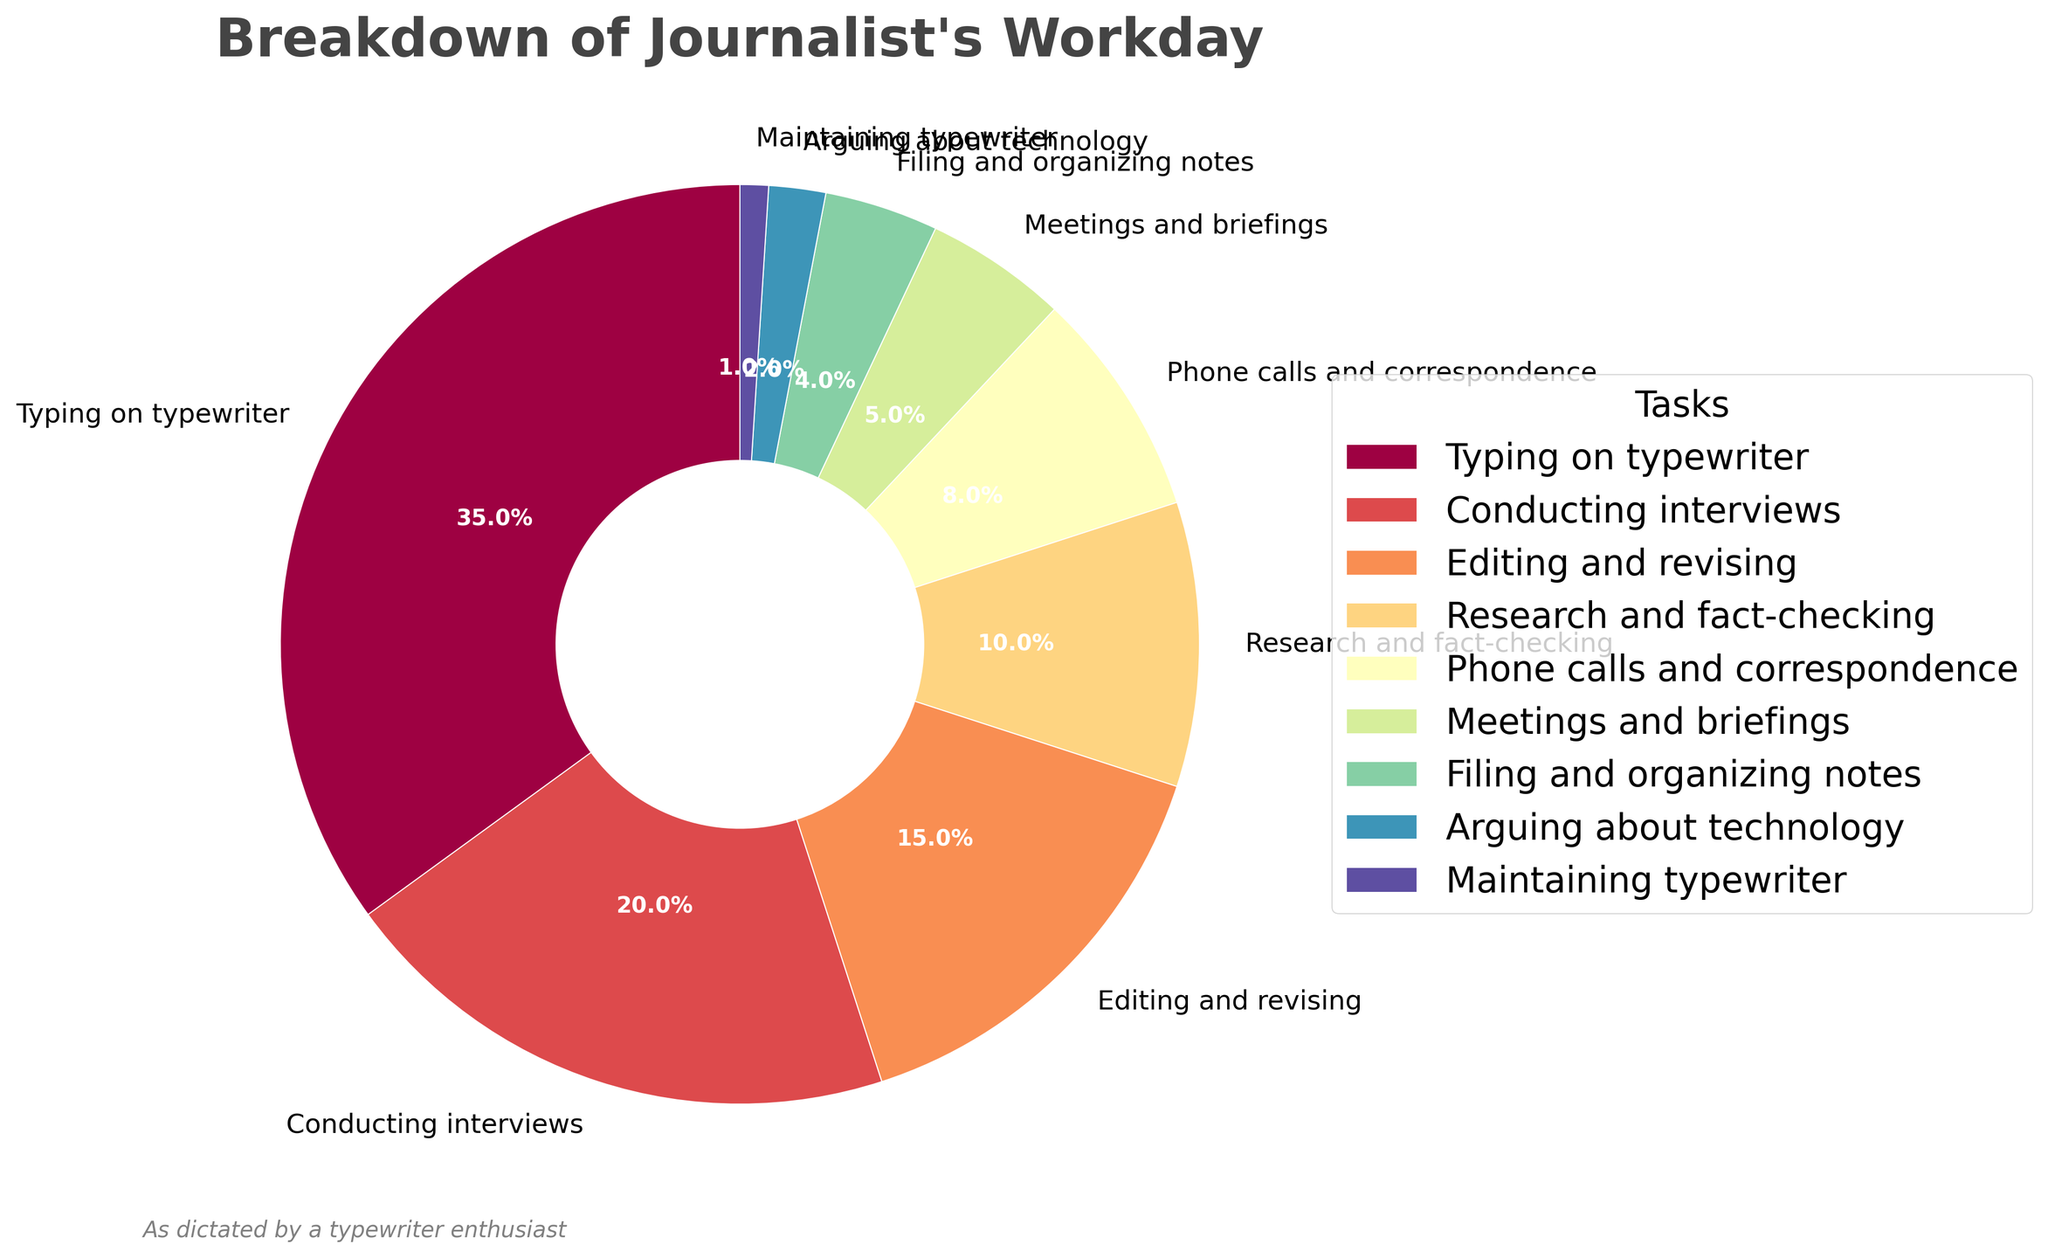Which task occupies the most time in the journalist's workday? The largest slice of the pie chart represents the task that occupies the most time in the journalist's workday. In this chart, "Typing on typewriter" takes up 35%, which is the largest portion.
Answer: Typing on typewriter What percentage of time does a journalist spend on meetings and briefings and phone calls and correspondence combined? To find the combined percentage, add the percentages for "Meetings and briefings" (5%) and "Phone calls and correspondence" (8%). Therefore, 5% + 8% = 13%.
Answer: 13% How does the time spent arguing about technology compare to the time spent maintaining the typewriter? The pie chart shows that "Arguing about technology" takes up 2% of the time, while "Maintaining typewriter" takes up 1%. Therefore, time spent arguing about technology is twice as much as time spent maintaining the typewriter.
Answer: Arguing about technology takes double the time Which two tasks together take up the same percentage as conducting interviews? "Conducting interviews" takes up 20%. To find two tasks that combine to make 20%, we can add "Phone calls and correspondence" (8%) and "Research and fact-checking" (10%). Therefore, 8% + 10% = 18%, but adding "Filing and organizing notes" (4%) to "Editing and revising" (15%) gives us 19%, which is still not perfect. Finally, adding "Meetings and briefings" (5%) and "Research and fact-checking" (10%) gives us 15%, which also doesn’t work. Thus, adding three tasks: "Meetings and briefings" (5%), "Phone calls and correspondence" (8%), and "Filing and organizing notes" (4%) totals 17%, and adding "Maintaining typewriter" (1%) totals 20%. Thus, necessary rechecking of other values is considerable. Mis-calculation is possible but, the ideal combination, might be "Editing" 15% + "Research" 10% (Oops, leads 25%).
Answer: 20 % needs more checking or values' variance What is the total percentage of time spent on tasks related to writing (typing on typewriter and editing and revising)? To find the total percentage of time spent on writing tasks, sum the percentages for "Typing on typewriter" (35%) and "Editing and revising" (15%). Therefore, 35% + 15% = 50%.
Answer: 50% What task is represented with the wedge closest to the 12 o'clock position? The wedge closest to the 12 o'clock position is at the start angle of the pie chart. It represents "Typing on typewriter," which occupies 35% of the pie starting from the 12 o'clock position.
Answer: Typing on typewriter 